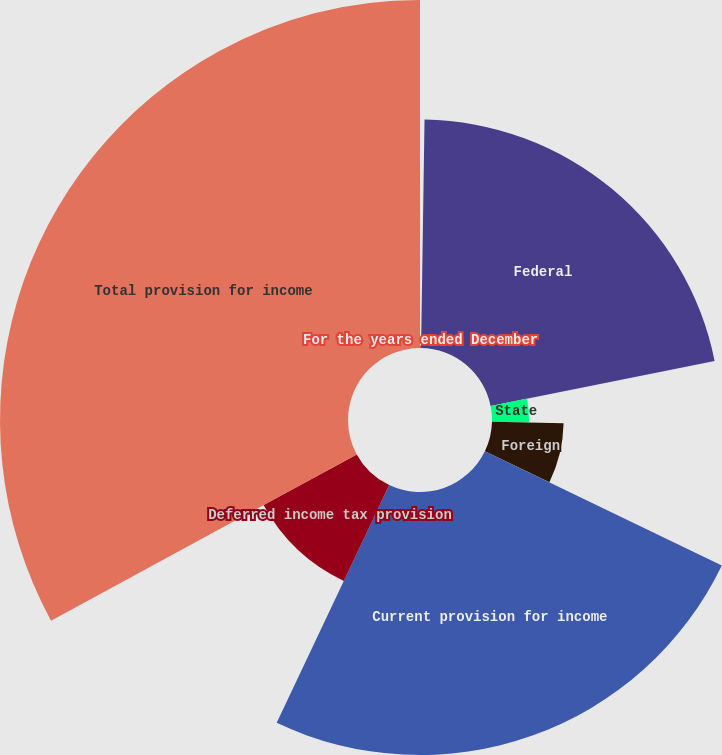<chart> <loc_0><loc_0><loc_500><loc_500><pie_chart><fcel>For the years ended December<fcel>Federal<fcel>State<fcel>Foreign<fcel>Current provision for income<fcel>Deferred income tax provision<fcel>Total provision for income<nl><fcel>0.24%<fcel>21.62%<fcel>3.51%<fcel>6.78%<fcel>24.89%<fcel>10.04%<fcel>32.93%<nl></chart> 